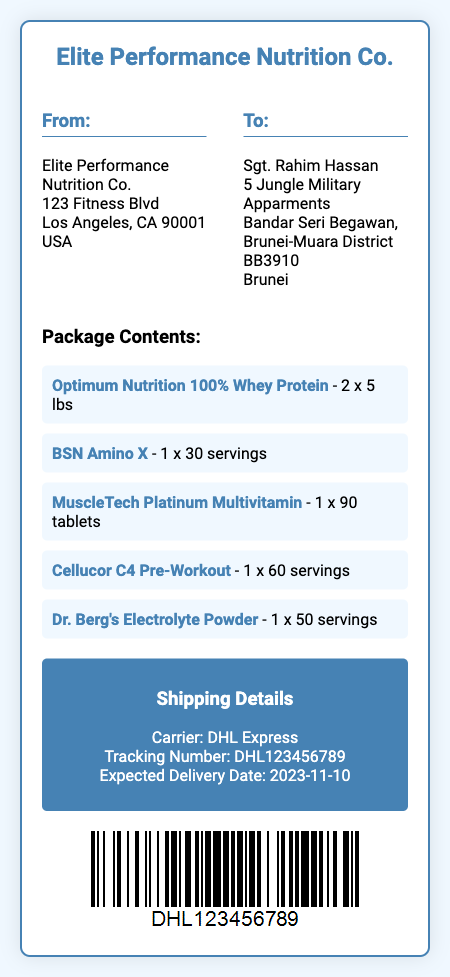what is the sender's company name? The sender's company name is listed at the top of the shipping label.
Answer: Elite Performance Nutrition Co who is the recipient of the package? The recipient's name is provided in the "To" section of the shipping label.
Answer: Sgt. Rahim Hassan what is the expected delivery date? The expected delivery date is mentioned in the shipping details section.
Answer: 2023-11-10 how many servings are in the BSN Amino X? The number of servings for BSN Amino X is mentioned next to the product name in the package contents.
Answer: 30 servings which carrier will deliver the package? The carrier's name is stated in the shipping details section of the label.
Answer: DHL Express what is the tracking number for the shipment? The tracking number is specified in the shipping details and used for tracking the package.
Answer: DHL123456789 how many tablets are in the MuscleTech Platinum Multivitamin? The number of tablets in the MuscleTech Platinum Multivitamin is provided in the item description.
Answer: 90 tablets what is the weight of the Optimum Nutrition 100% Whey Protein? The weight of the Optimum Nutrition product is specified next to the item name.
Answer: 2 x 5 lbs what color is the shipping label's background? The background color of the shipping label is described in the document's styling section.
Answer: f0f8ff 